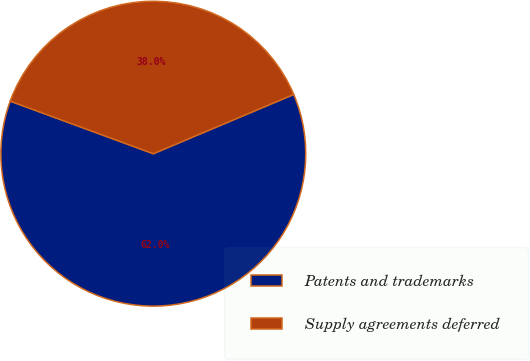Convert chart to OTSL. <chart><loc_0><loc_0><loc_500><loc_500><pie_chart><fcel>Patents and trademarks<fcel>Supply agreements deferred<nl><fcel>61.96%<fcel>38.04%<nl></chart> 